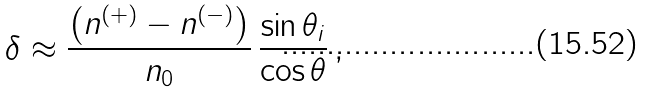<formula> <loc_0><loc_0><loc_500><loc_500>\delta \approx \frac { \left ( n ^ { ( + ) } - n ^ { ( - ) } \right ) } { n _ { 0 } } \, \frac { \sin \theta _ { i } } { \cos \theta } \, ,</formula> 